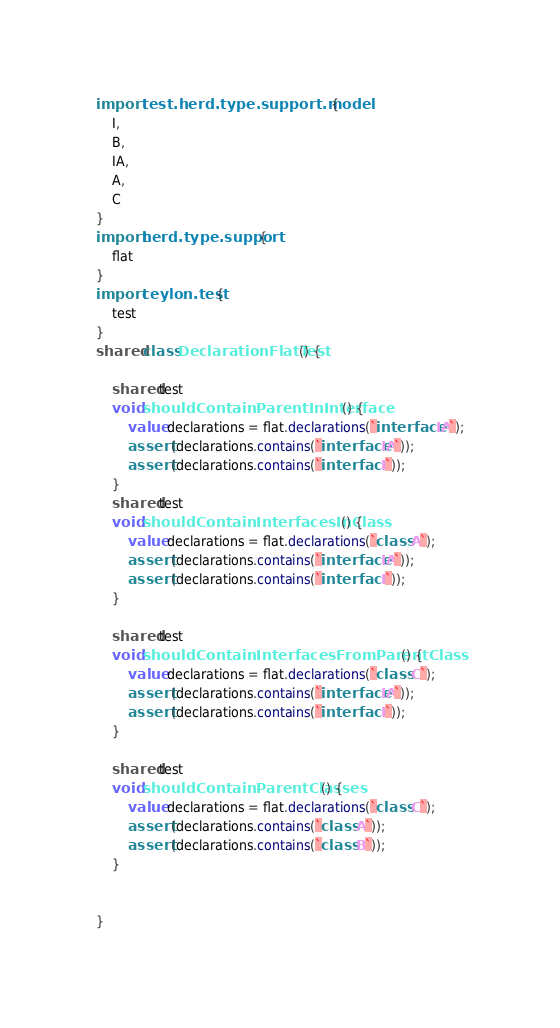<code> <loc_0><loc_0><loc_500><loc_500><_Ceylon_>import test.herd.type.support.model {
	I,
	B,
	IA,
	A,
	C
}
import herd.type.support {
	flat
}
import ceylon.test {
	test
}
shared class DeclarationFlatTest() {
	
	shared test
	void shouldContainParentInInterface() {
		value declarations = flat.declarations(`interface IA`);
		assert (declarations.contains(`interface IA`));
		assert (declarations.contains(`interface I`));
	}
	shared test
	void shouldContainInterfacesInClass() {
		value declarations = flat.declarations(`class A`);
		assert (declarations.contains(`interface IA`));
		assert (declarations.contains(`interface I`));
	}
	
	shared test
	void shouldContainInterfacesFromParentClass() {
		value declarations = flat.declarations(`class C`);
		assert (declarations.contains(`interface IA`));
		assert (declarations.contains(`interface I`));
	}
	
	shared test
	void shouldContainParentClasses() {
		value declarations = flat.declarations(`class C`);
		assert (declarations.contains(`class A`));
		assert (declarations.contains(`class B`));
	}
		
	
}</code> 